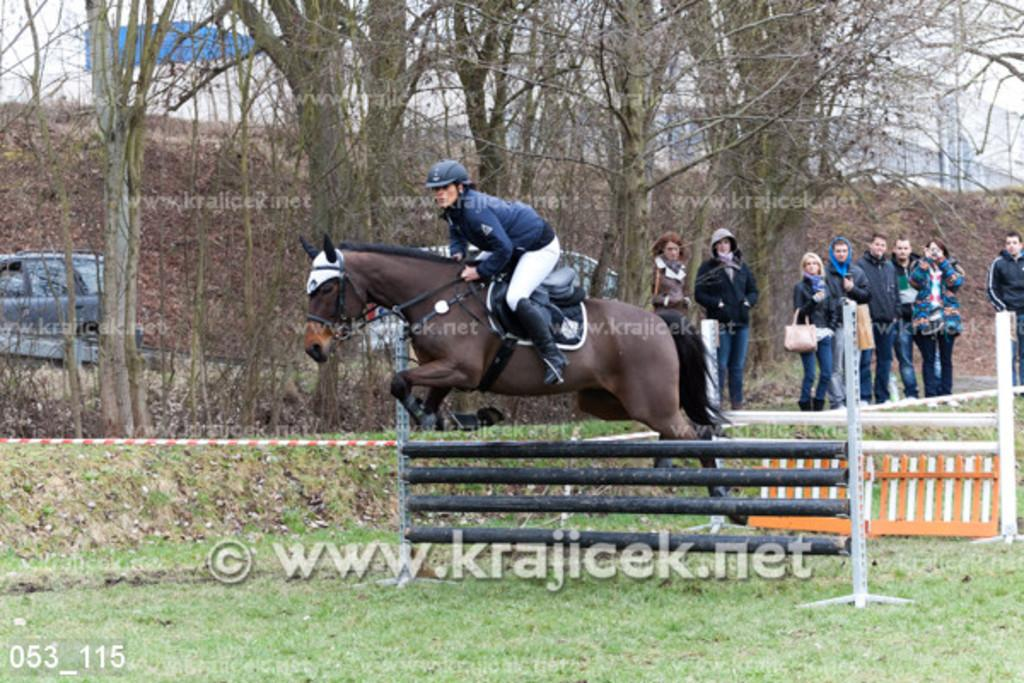What is the main subject of the image? There is a person riding a horse in the image. What color is the horse? The horse is brown in color. What can be seen on the right side of the image? There are people standing on the right side of the image. What are the people wearing? The people are wearing black coats. What is located in the middle of the image? There are trees in the middle of the image. What type of string is being used to lift the horse in the image? There is no string or lifting action depicted in the image; the person is simply riding the horse. 